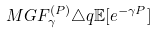<formula> <loc_0><loc_0><loc_500><loc_500>M G F ^ { ( P ) } _ { \gamma } \triangle q \mathbb { E } [ e ^ { - \gamma P } ]</formula> 